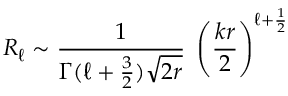<formula> <loc_0><loc_0><loc_500><loc_500>R _ { \ell } \sim { \frac { 1 } { \Gamma ( \ell + { \frac { 3 } { 2 } } ) \sqrt { 2 r } } } \, \left ( { \frac { k r } { 2 } } \right ) ^ { \ell + { \frac { 1 } { 2 } } }</formula> 